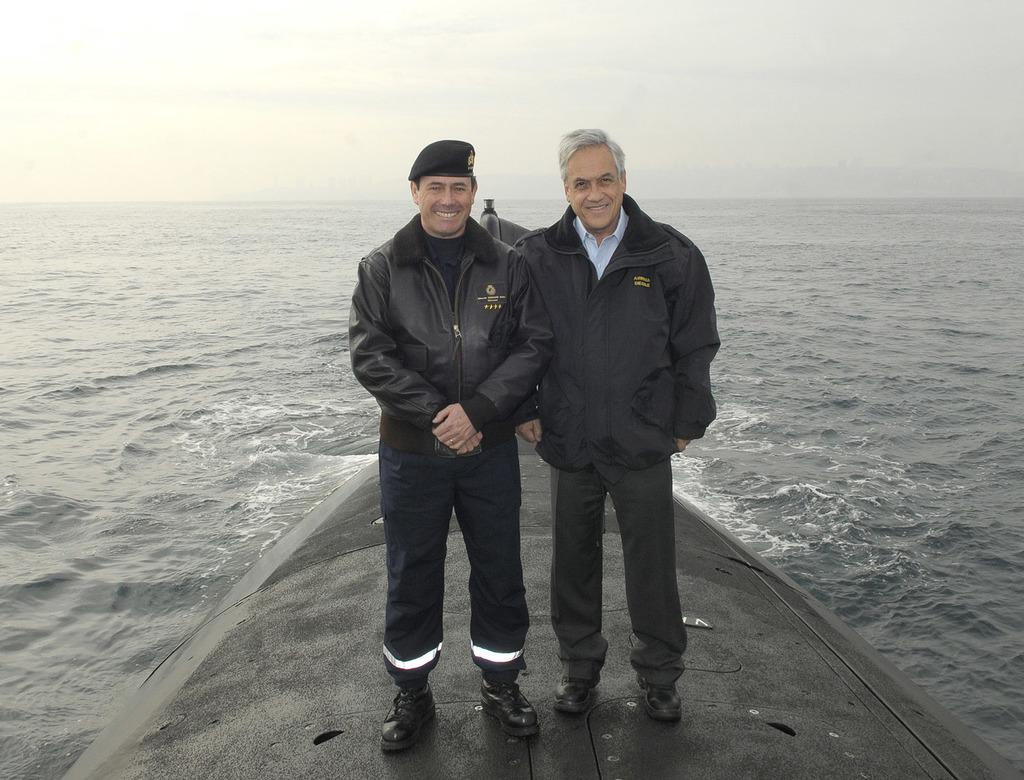How many people are in the image? There are two men in the image. What are the men standing on? The men are standing on a submarine. Where is the submarine located? The submarine is in a large water body. What can be seen in the background of the image? The sky is visible in the background of the image. What is the condition of the sky in the image? The sky looks cloudy in the image. What type of bread is being served on the submarine in the image? There is no bread visible in the image; it features two men standing on a submarine in a large water body. What is the skin condition of the men in the image? There is no information about the men's skin condition in the image. 